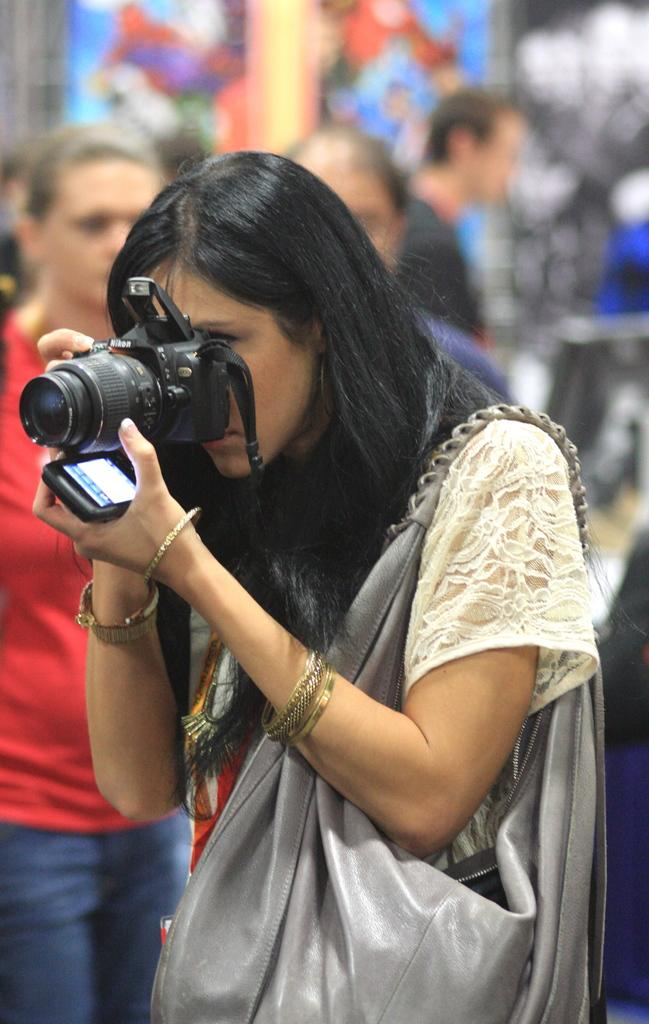Who is the main subject in the image? There is a woman in the image. What is the woman doing in the image? The woman is standing and holding a camera and a mobile. What can be seen in the background of the image? There are people walking in the background of the image. Can you tell me how many bears are visible in the image? There are no bears present in the image. What type of room is the woman standing in? The provided facts do not mention a room, so it cannot be determined from the image. 